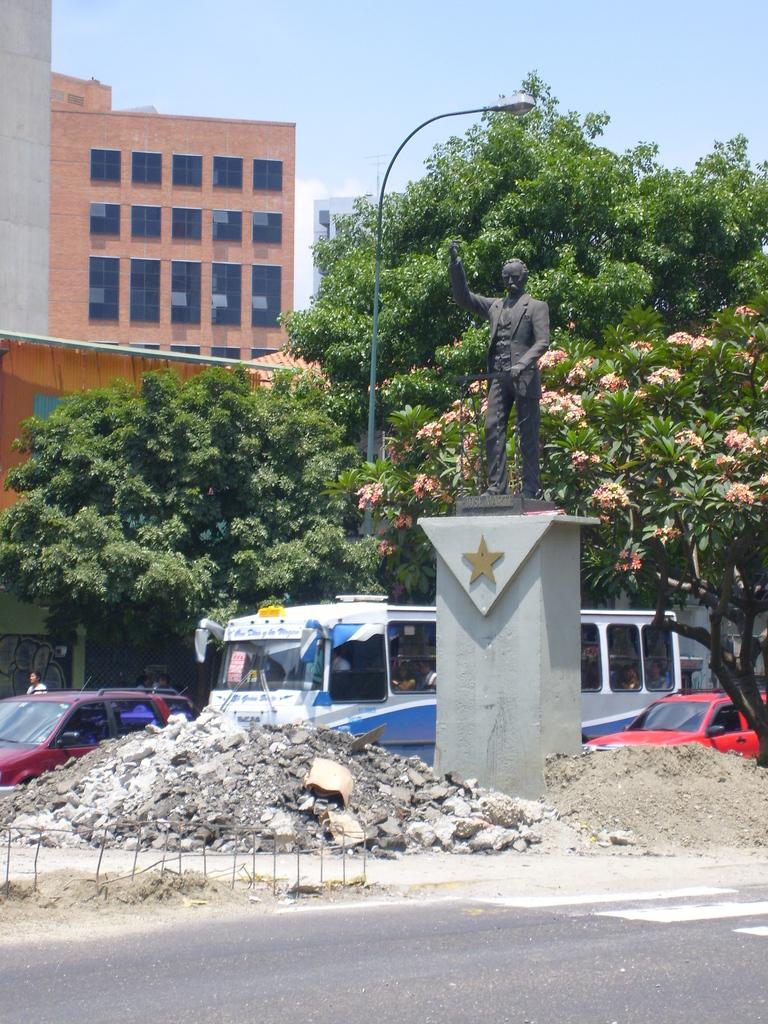What is the main feature of the image? There is a road in the image. Can you describe any other elements in the image? Yes, there is a person, a statue, vehicles, stones, rods, trees, buildings, and the sky is visible in the background. What type of voice can be heard coming from the statue in the image? There is no voice coming from the statue in the image, as statues are typically inanimate objects and do not produce sound. 